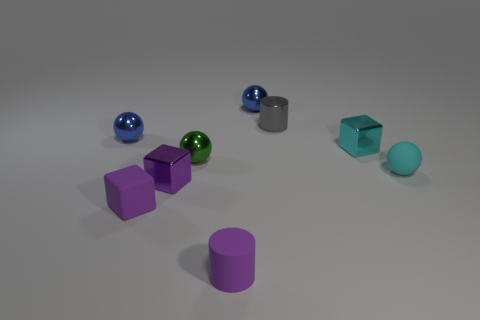Subtract all gray spheres. Subtract all purple blocks. How many spheres are left? 4 Add 1 small purple matte things. How many objects exist? 10 Subtract all cylinders. How many objects are left? 7 Add 4 cyan metal blocks. How many cyan metal blocks exist? 5 Subtract 1 purple cubes. How many objects are left? 8 Subtract all purple shiny objects. Subtract all small metal cylinders. How many objects are left? 7 Add 4 tiny cyan blocks. How many tiny cyan blocks are left? 5 